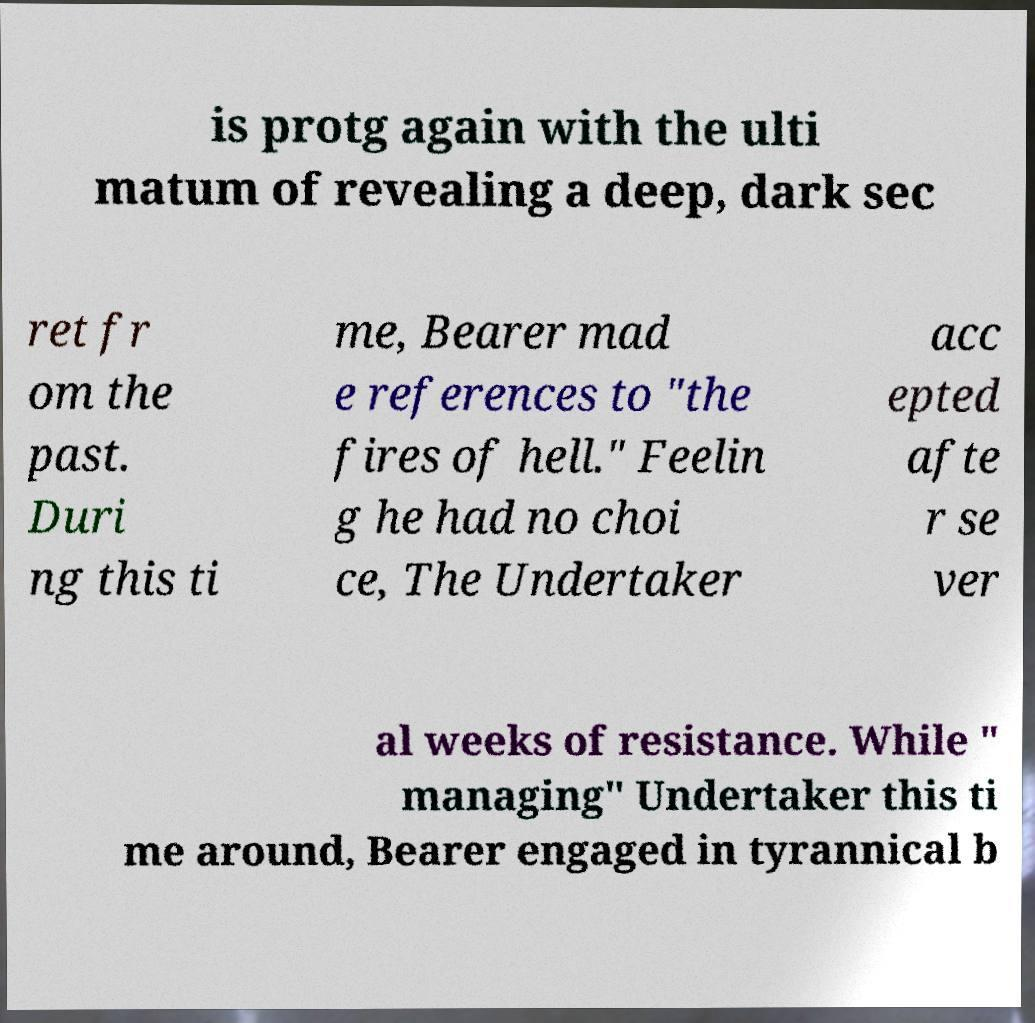Please read and relay the text visible in this image. What does it say? is protg again with the ulti matum of revealing a deep, dark sec ret fr om the past. Duri ng this ti me, Bearer mad e references to "the fires of hell." Feelin g he had no choi ce, The Undertaker acc epted afte r se ver al weeks of resistance. While " managing" Undertaker this ti me around, Bearer engaged in tyrannical b 